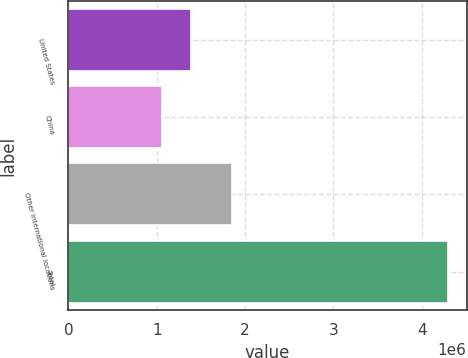Convert chart to OTSL. <chart><loc_0><loc_0><loc_500><loc_500><bar_chart><fcel>United States<fcel>China<fcel>Other international locations<fcel>Total<nl><fcel>1.38776e+06<fcel>1.06506e+06<fcel>1.84732e+06<fcel>4.29206e+06<nl></chart> 